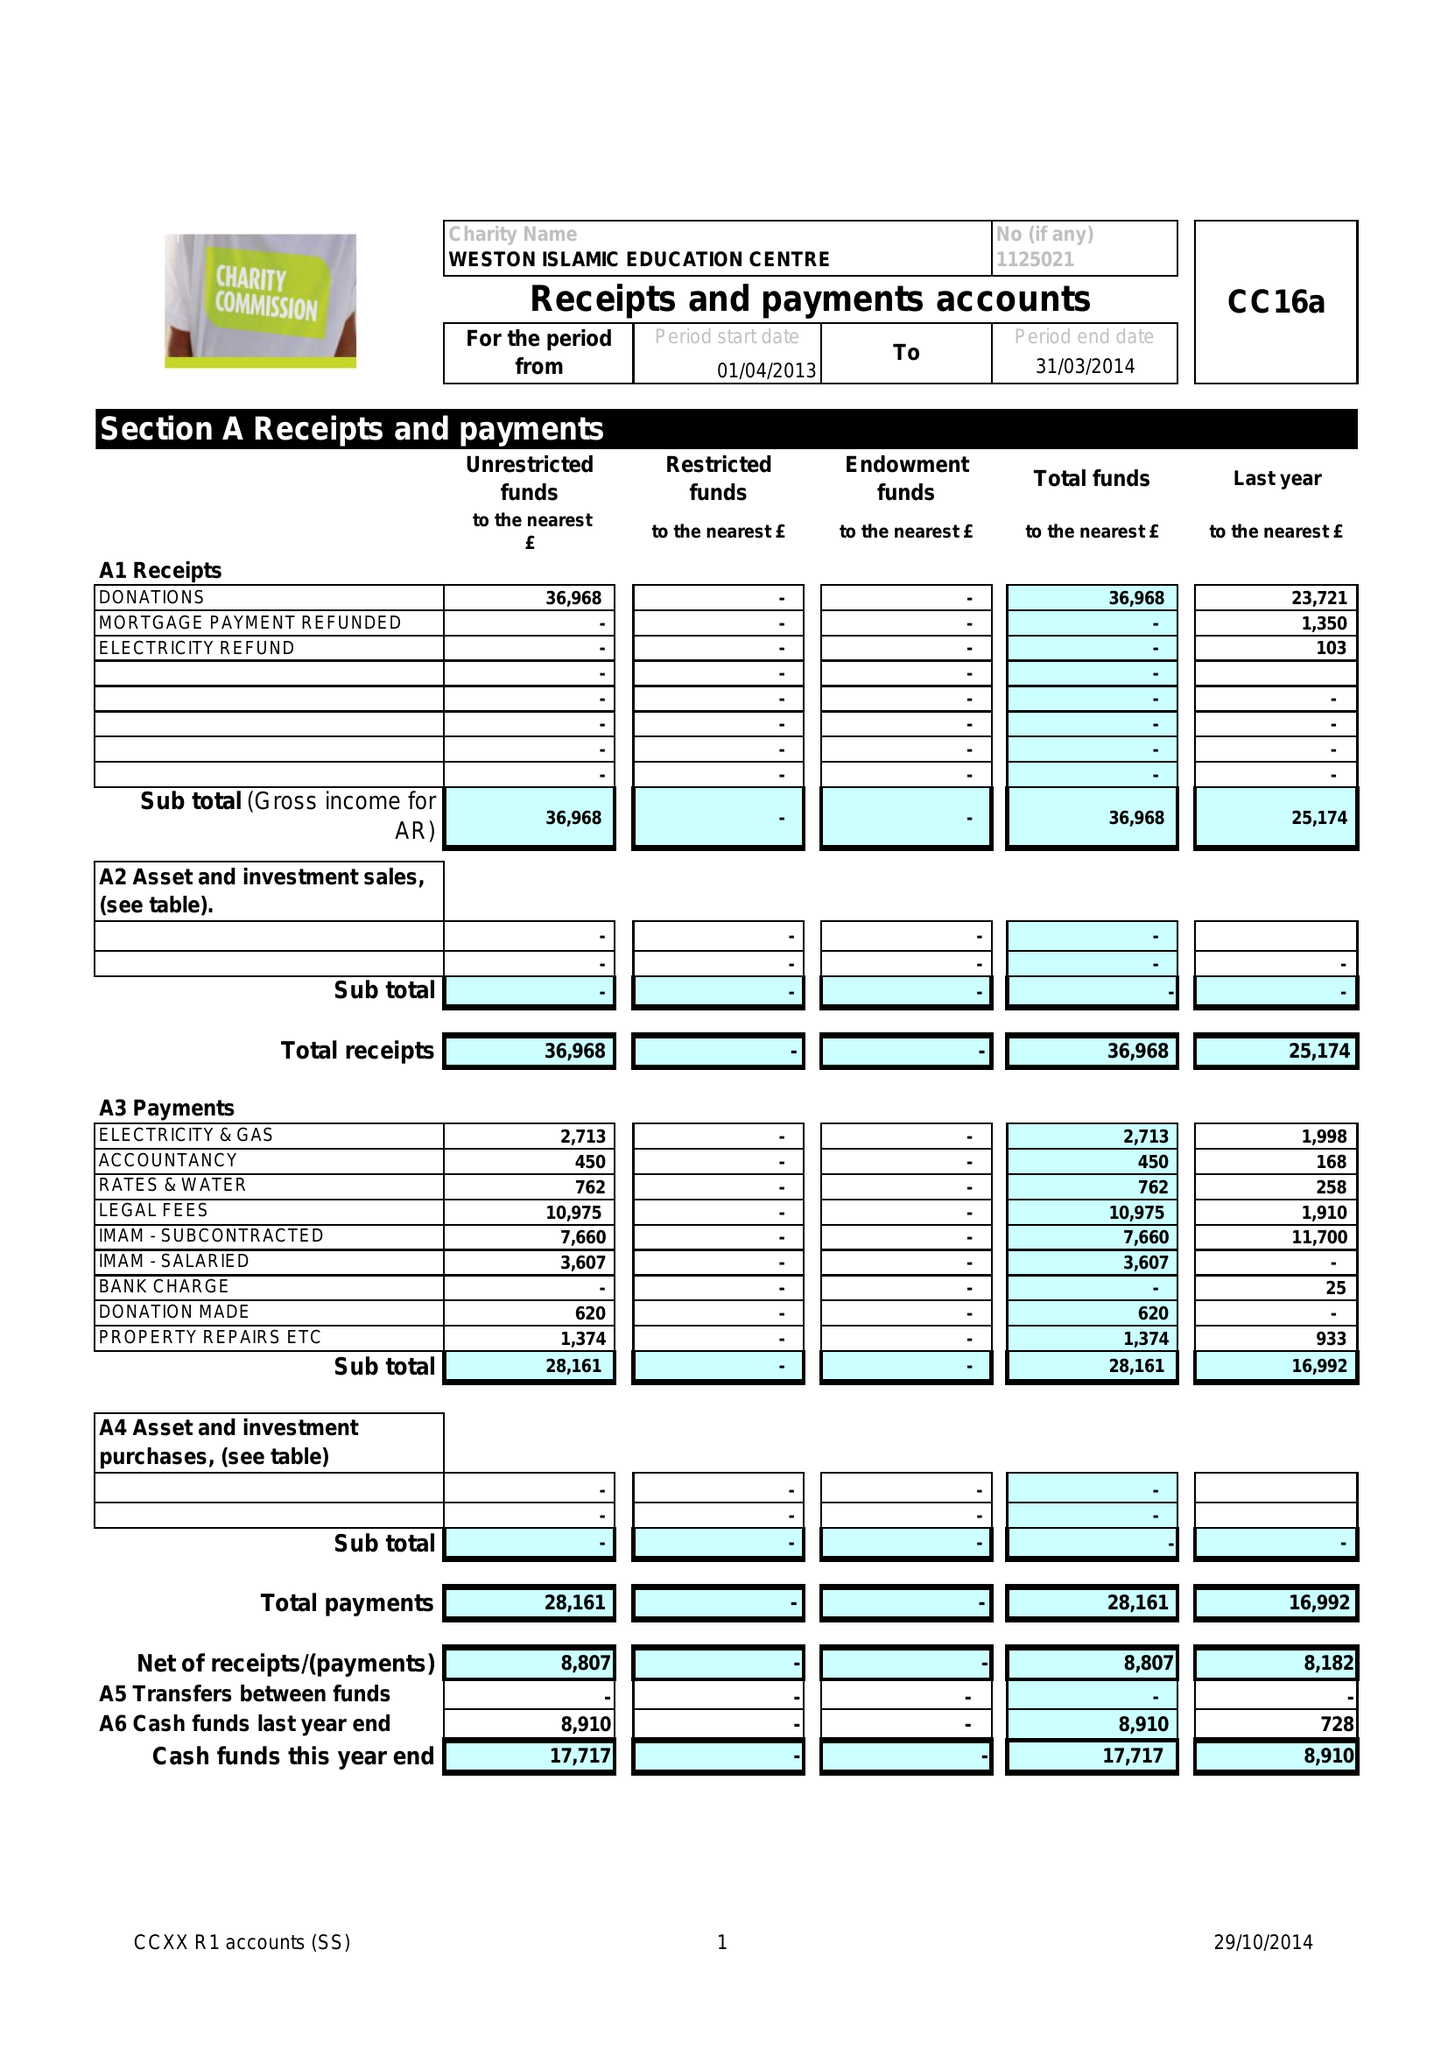What is the value for the report_date?
Answer the question using a single word or phrase. 2014-03-31 